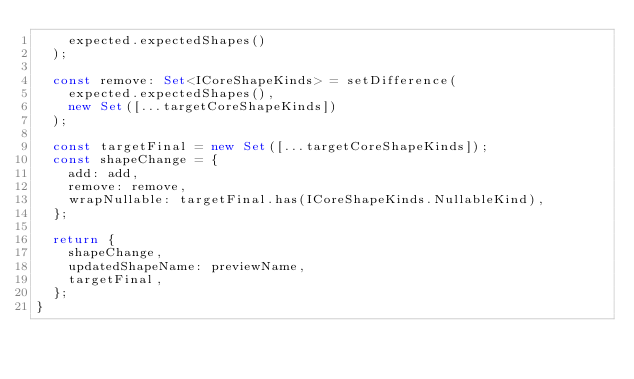<code> <loc_0><loc_0><loc_500><loc_500><_TypeScript_>    expected.expectedShapes()
  );

  const remove: Set<ICoreShapeKinds> = setDifference(
    expected.expectedShapes(),
    new Set([...targetCoreShapeKinds])
  );

  const targetFinal = new Set([...targetCoreShapeKinds]);
  const shapeChange = {
    add: add,
    remove: remove,
    wrapNullable: targetFinal.has(ICoreShapeKinds.NullableKind),
  };

  return {
    shapeChange,
    updatedShapeName: previewName,
    targetFinal,
  };
}
</code> 